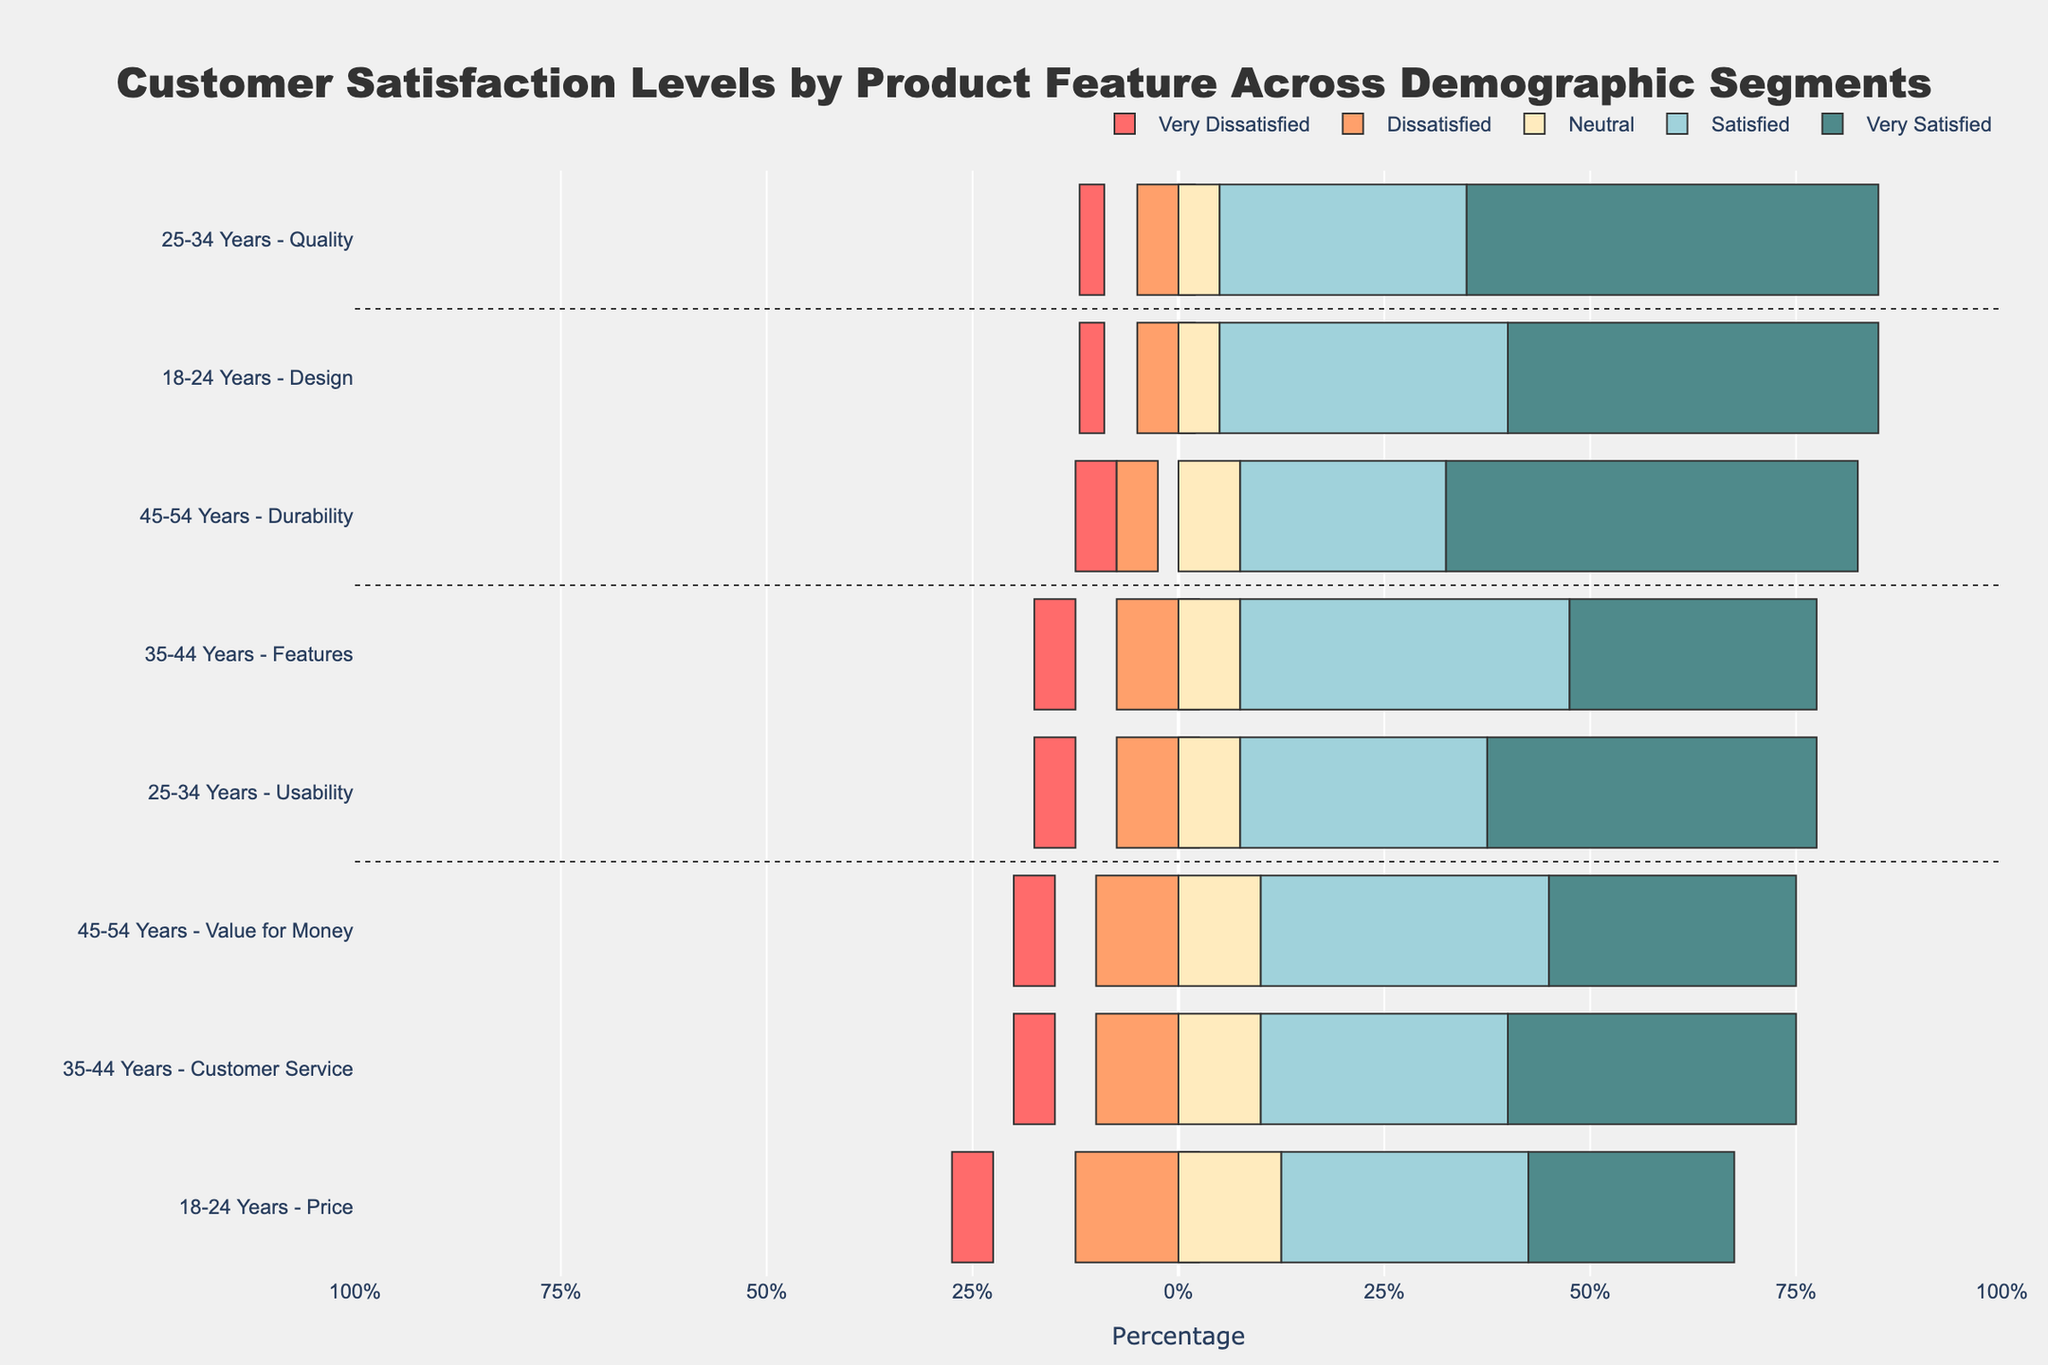What's the satisfaction level with the highest percentage for the 18-24 years demographic segment's design feature? By examining the diverging stacked bar chart, we can see that for the design feature in the 18-24 years demographic, the bar section with the highest percentage is "Very Satisfied", which visually stands out from the rest.
Answer: Very Satisfied Which product feature has the highest satisfaction among the 45-54 years demographic segment? Looking at the diverging stacked bar chart, we observe the segment for the 45-54 years demographic. The "Durability" feature shows the highest “Very Satisfied” and “Satisfied” percentages combined when compared to "Value for Money".
Answer: Durability Compare the satisfaction levels for the "Price" feature between the 18-24 years and 25-34 years demographic segments. Examining the bar sections for the "Price" feature in both demographic segments on the diverging stacked bar chart, we see that the percentage of "Very Satisfied" and "Satisfied" is generally higher for the 18-24 years segment than for the 25-34 years segment.
Answer: Higher for 18-24 years What's the difference in the percentage of "Very Satisfied" customers between the "Quality" feature for the 25-34 years segment and the "Usability" feature for the same segment? For the 25-34 years segment: "Very Satisfied" percentage for "Quality" is 50%, whereas for "Usability" it is 40%. Subtracting these two, we get 50% - 40% = 10%.
Answer: 10% Which demographic segment has the most "Neutral" responses for the "Customer Service" feature? Referring to the chart, we find the "Customer Service" feature and see that the 35-44 years demographic segment has the highest relative length of the "Neutral" bar section, standing out from others.
Answer: 35-44 years What is the combined percentage of "Dissatisfied" and "Very Dissatisfied" customers for the "Design" feature in the 18-24 years demographic segment? For the "Design" feature in the 18-24 years segment, the "Dissatisfied" percentage is 7% and the "Very Dissatisfied" percentage is 3%. Adding these together, we get 7% + 3% = 10%.
Answer: 10% How does the "Satisfied" satisfaction level for the "Features" feature in the 35-44 years segment compare to the "Value for Money" feature in the 45-54 years segment? In the diverging stacked bar chart, we observe the "Satisfied" bar sections for "Features" in the 35-44 years and "Value for Money" in the 45-54 years segments. Both segments show 40% and 35%, respectively. Therefore, the "Satisfied" satisfaction level is higher for "Features" for the 35-44 years segment.
Answer: Higher for Features in 35-44 years What is the total percentage of customers who are "Very Satisfied" with "Customer Service" in the 35-44 years demographic segment and "Durability" in the 45-54 years demographic segment? From the chart, the "Very Satisfied" percentage for "Customer Service" in the 35-44 years segment is 35%, and for "Durability" in the 45-54 years, it is 50%. Adding these percentages together gives us 35% + 50% = 85%.
Answer: 85% 